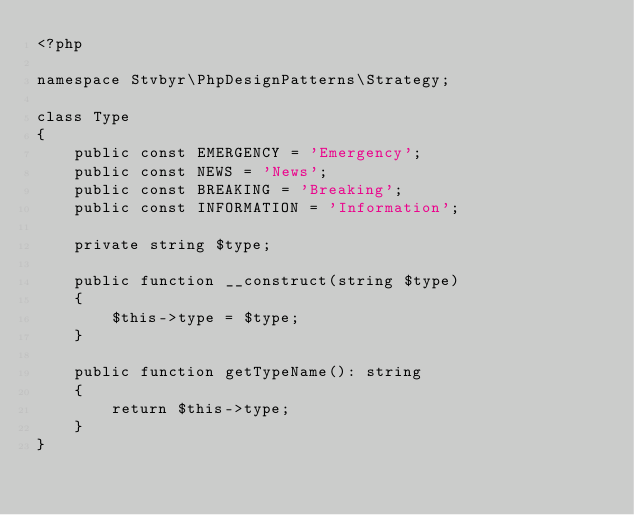Convert code to text. <code><loc_0><loc_0><loc_500><loc_500><_PHP_><?php

namespace Stvbyr\PhpDesignPatterns\Strategy;

class Type
{
    public const EMERGENCY = 'Emergency';
    public const NEWS = 'News';
    public const BREAKING = 'Breaking';
    public const INFORMATION = 'Information';

    private string $type;

    public function __construct(string $type)
    {
        $this->type = $type;
    }

    public function getTypeName(): string
    {
        return $this->type;
    }
}
</code> 